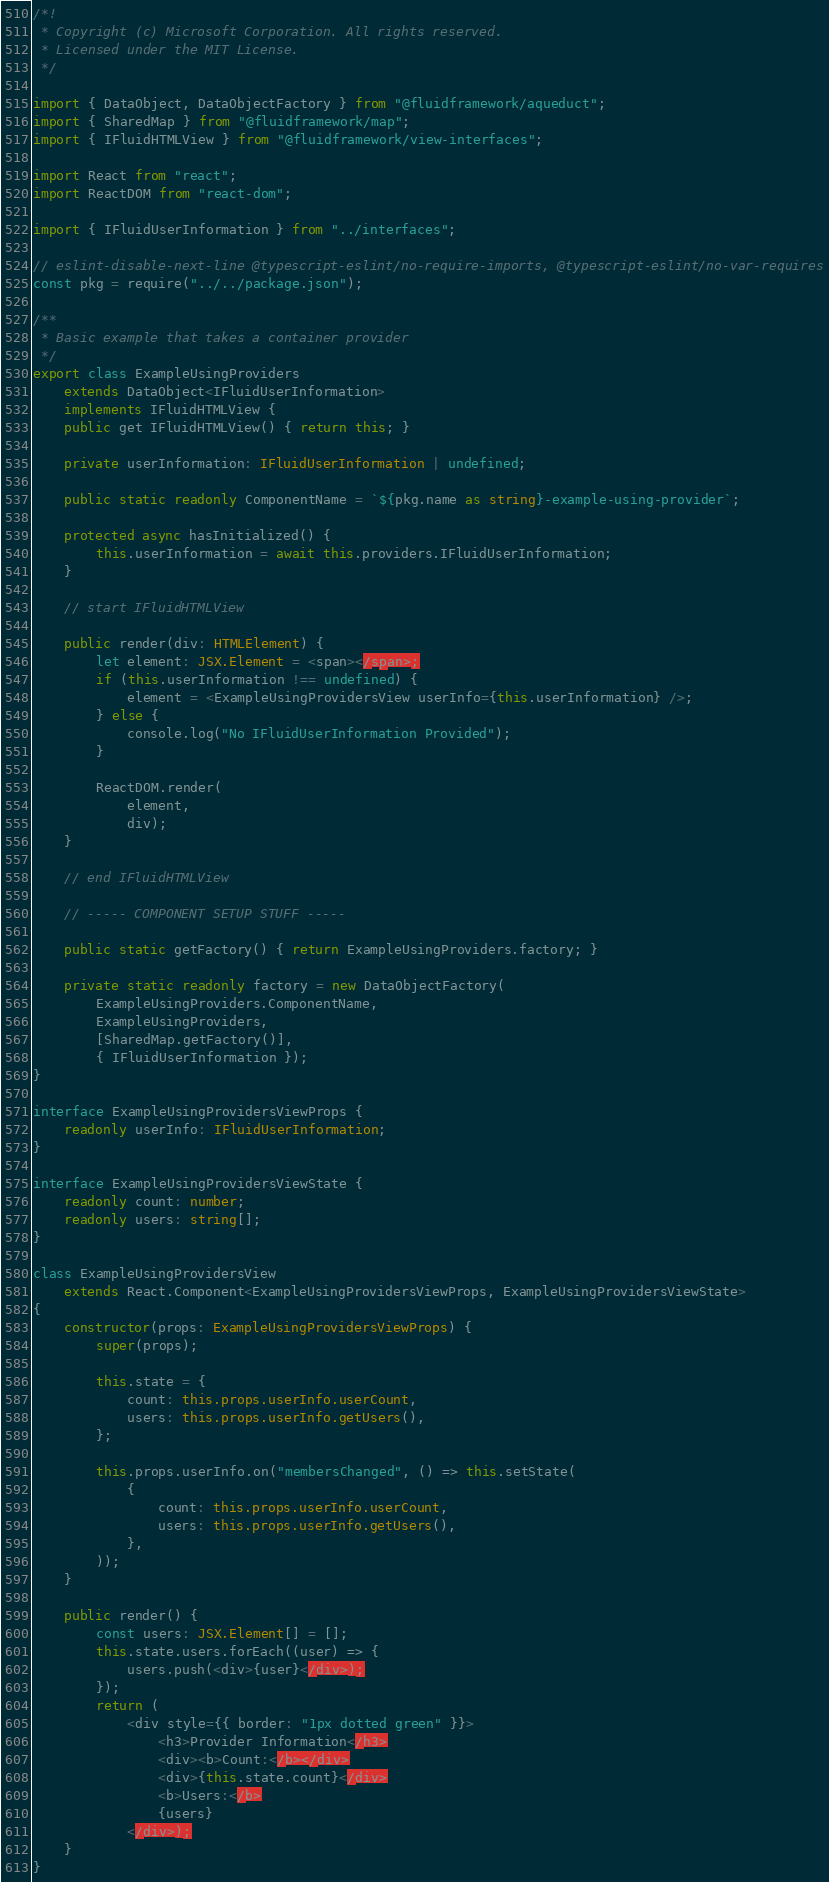<code> <loc_0><loc_0><loc_500><loc_500><_TypeScript_>/*!
 * Copyright (c) Microsoft Corporation. All rights reserved.
 * Licensed under the MIT License.
 */

import { DataObject, DataObjectFactory } from "@fluidframework/aqueduct";
import { SharedMap } from "@fluidframework/map";
import { IFluidHTMLView } from "@fluidframework/view-interfaces";

import React from "react";
import ReactDOM from "react-dom";

import { IFluidUserInformation } from "../interfaces";

// eslint-disable-next-line @typescript-eslint/no-require-imports, @typescript-eslint/no-var-requires
const pkg = require("../../package.json");

/**
 * Basic example that takes a container provider
 */
export class ExampleUsingProviders
    extends DataObject<IFluidUserInformation>
    implements IFluidHTMLView {
    public get IFluidHTMLView() { return this; }

    private userInformation: IFluidUserInformation | undefined;

    public static readonly ComponentName = `${pkg.name as string}-example-using-provider`;

    protected async hasInitialized() {
        this.userInformation = await this.providers.IFluidUserInformation;
    }

    // start IFluidHTMLView

    public render(div: HTMLElement) {
        let element: JSX.Element = <span></span>;
        if (this.userInformation !== undefined) {
            element = <ExampleUsingProvidersView userInfo={this.userInformation} />;
        } else {
            console.log("No IFluidUserInformation Provided");
        }

        ReactDOM.render(
            element,
            div);
    }

    // end IFluidHTMLView

    // ----- COMPONENT SETUP STUFF -----

    public static getFactory() { return ExampleUsingProviders.factory; }

    private static readonly factory = new DataObjectFactory(
        ExampleUsingProviders.ComponentName,
        ExampleUsingProviders,
        [SharedMap.getFactory()],
        { IFluidUserInformation });
}

interface ExampleUsingProvidersViewProps {
    readonly userInfo: IFluidUserInformation;
}

interface ExampleUsingProvidersViewState {
    readonly count: number;
    readonly users: string[];
}

class ExampleUsingProvidersView
    extends React.Component<ExampleUsingProvidersViewProps, ExampleUsingProvidersViewState>
{
    constructor(props: ExampleUsingProvidersViewProps) {
        super(props);

        this.state = {
            count: this.props.userInfo.userCount,
            users: this.props.userInfo.getUsers(),
        };

        this.props.userInfo.on("membersChanged", () => this.setState(
            {
                count: this.props.userInfo.userCount,
                users: this.props.userInfo.getUsers(),
            },
        ));
    }

    public render() {
        const users: JSX.Element[] = [];
        this.state.users.forEach((user) => {
            users.push(<div>{user}</div>);
        });
        return (
            <div style={{ border: "1px dotted green" }}>
                <h3>Provider Information</h3>
                <div><b>Count:</b></div>
                <div>{this.state.count}</div>
                <b>Users:</b>
                {users}
            </div>);
    }
}
</code> 